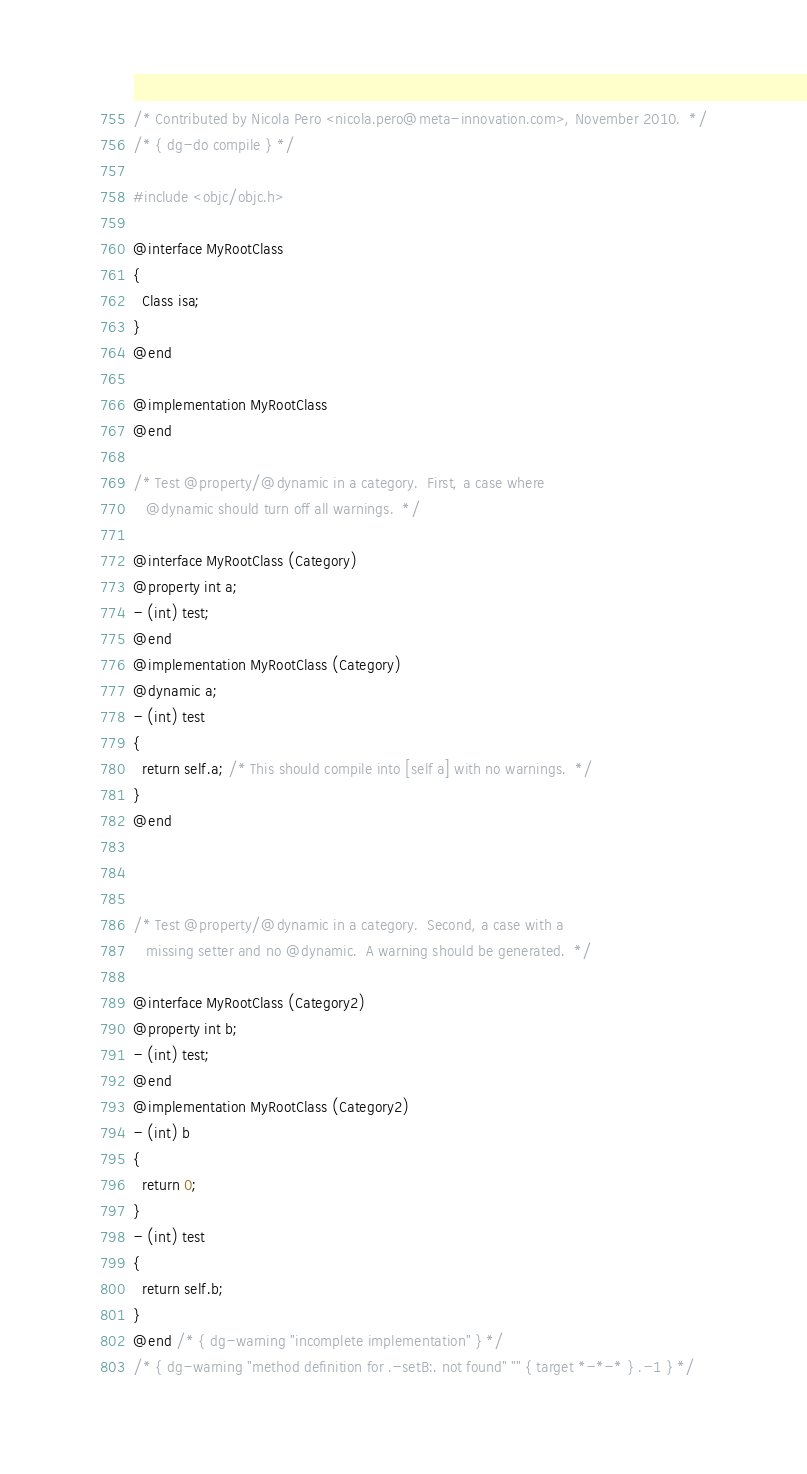<code> <loc_0><loc_0><loc_500><loc_500><_ObjectiveC_>/* Contributed by Nicola Pero <nicola.pero@meta-innovation.com>, November 2010.  */
/* { dg-do compile } */

#include <objc/objc.h>

@interface MyRootClass
{
  Class isa;
}
@end

@implementation MyRootClass
@end

/* Test @property/@dynamic in a category.  First, a case where
   @dynamic should turn off all warnings.  */

@interface MyRootClass (Category)
@property int a;
- (int) test;
@end
@implementation MyRootClass (Category)
@dynamic a;
- (int) test
{
  return self.a; /* This should compile into [self a] with no warnings.  */
}
@end



/* Test @property/@dynamic in a category.  Second, a case with a
   missing setter and no @dynamic.  A warning should be generated.  */

@interface MyRootClass (Category2)
@property int b;
- (int) test;
@end
@implementation MyRootClass (Category2)
- (int) b
{
  return 0;
}
- (int) test
{
  return self.b;
}
@end /* { dg-warning "incomplete implementation" } */
/* { dg-warning "method definition for .-setB:. not found" "" { target *-*-* } .-1 } */
</code> 